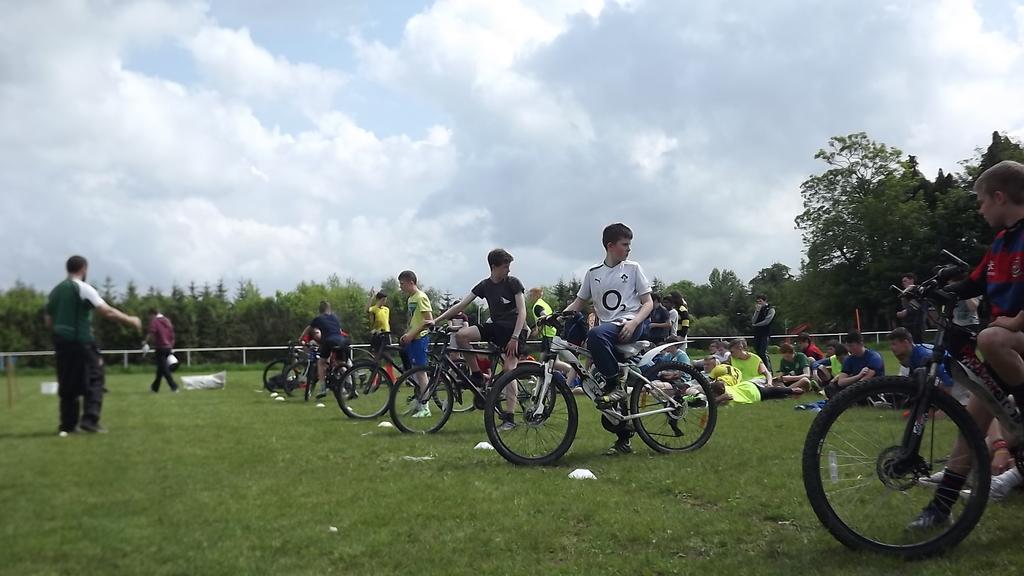Can you describe this image briefly? To the bottom of the image there is grass on the ground. There are few people with bicycles are on the ground. Behind them there are few people sitting on the grass. At the back of them there is a fencing. Behind the fencing there are many trees. To the top of the image there is a sky with clouds. 